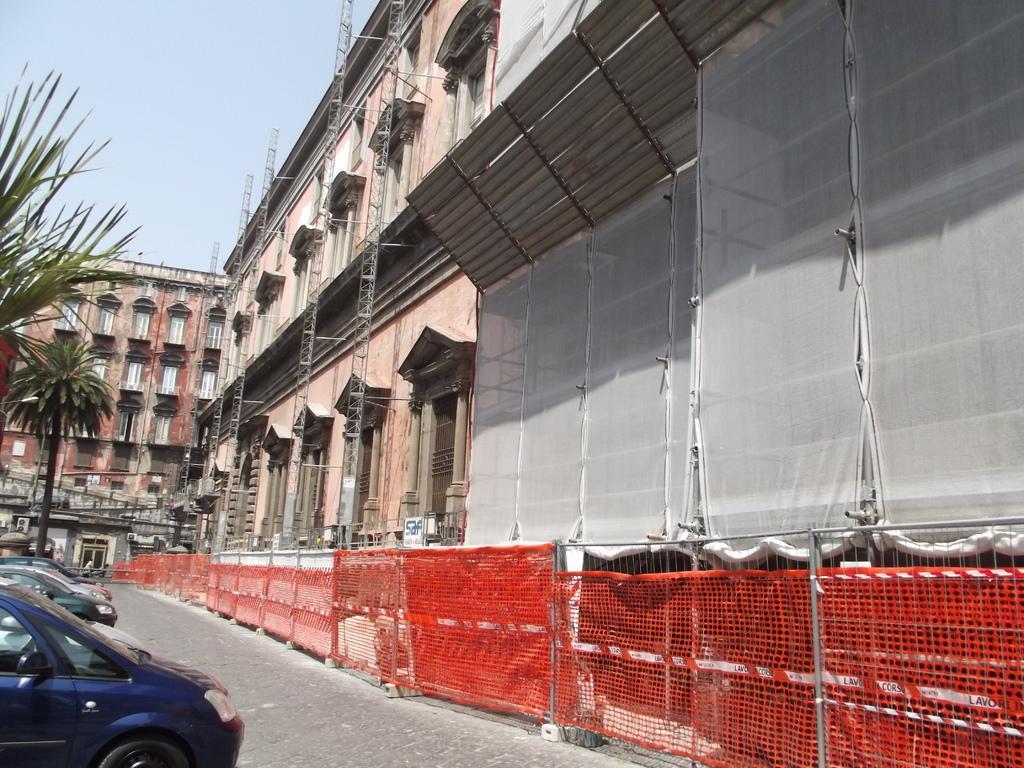Describe this image in one or two sentences. In this image there are building, on the road there are cars and trees, near to the building there is fencing. 